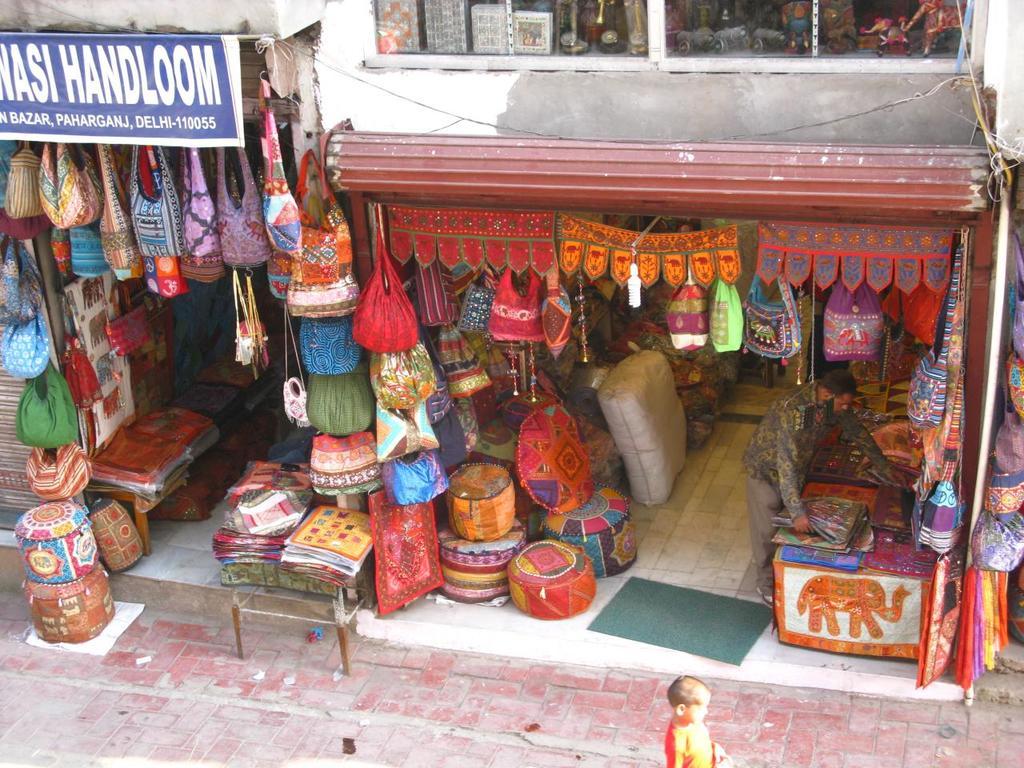What is being sold in the store on the left?
Your answer should be compact. Handloom. Is this a bazar?
Keep it short and to the point. Yes. 